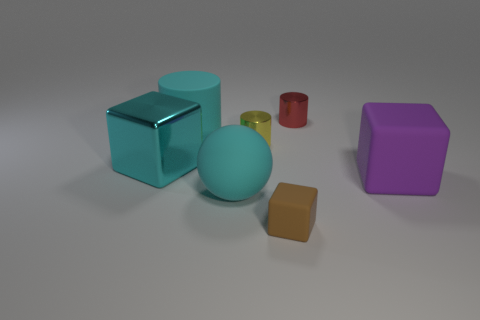Subtract all cyan shiny cubes. How many cubes are left? 2 Add 3 big red balls. How many objects exist? 10 Subtract 2 cubes. How many cubes are left? 1 Subtract all yellow balls. Subtract all brown cylinders. How many balls are left? 1 Subtract all big matte things. Subtract all large green rubber cubes. How many objects are left? 4 Add 2 cyan cubes. How many cyan cubes are left? 3 Add 5 large cyan rubber cylinders. How many large cyan rubber cylinders exist? 6 Subtract 1 yellow cylinders. How many objects are left? 6 Subtract all cubes. How many objects are left? 4 